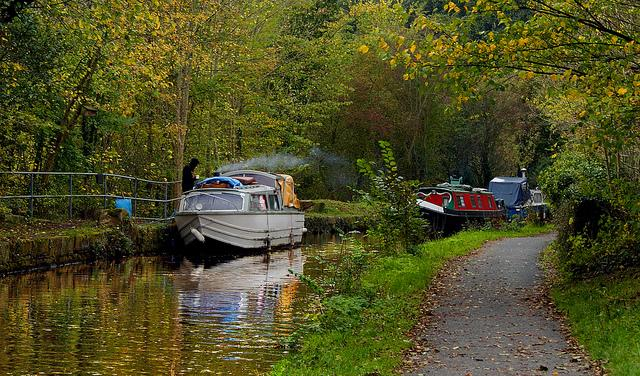What type byway is shown here? Please explain your reasoning. nature path. There is a small path next to the water. 